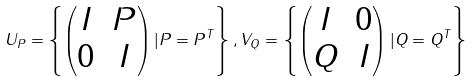Convert formula to latex. <formula><loc_0><loc_0><loc_500><loc_500>U _ { P } = \left \{ \begin{pmatrix} I & P \\ 0 & I \end{pmatrix} | P = P ^ { T } \right \} , V _ { Q } = \left \{ \begin{pmatrix} I & 0 \\ Q & I \end{pmatrix} | Q = Q ^ { T } \right \}</formula> 